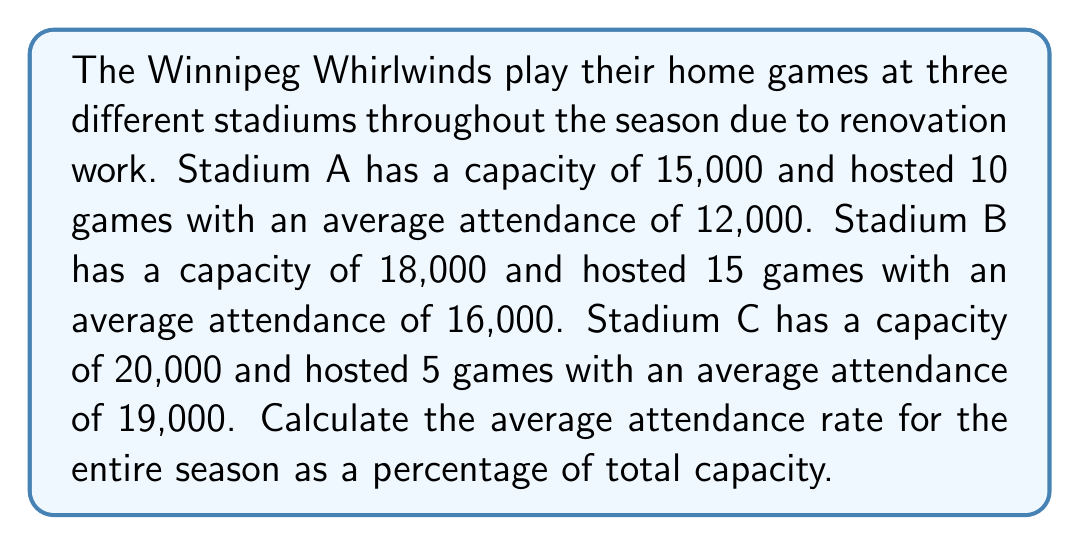Teach me how to tackle this problem. To solve this problem, we need to follow these steps:

1. Calculate the total attendance for each stadium:
   Stadium A: $10 \times 12,000 = 120,000$
   Stadium B: $15 \times 16,000 = 240,000$
   Stadium C: $5 \times 19,000 = 95,000$

2. Calculate the total attendance for the season:
   $120,000 + 240,000 + 95,000 = 455,000$

3. Calculate the total capacity for all games:
   Stadium A: $10 \times 15,000 = 150,000$
   Stadium B: $15 \times 18,000 = 270,000$
   Stadium C: $5 \times 20,000 = 100,000$
   Total capacity: $150,000 + 270,000 + 100,000 = 520,000$

4. Calculate the average attendance rate:
   $$\text{Average Attendance Rate} = \frac{\text{Total Attendance}}{\text{Total Capacity}} \times 100\%$$
   
   $$= \frac{455,000}{520,000} \times 100\%$$

5. Simplify the fraction and calculate the percentage:
   $$= \frac{455}{520} \times 100\% \approx 0.875 \times 100\% = 87.5\%$$

Therefore, the average attendance rate for the entire season is approximately 87.5% of the total capacity.
Answer: 87.5% 